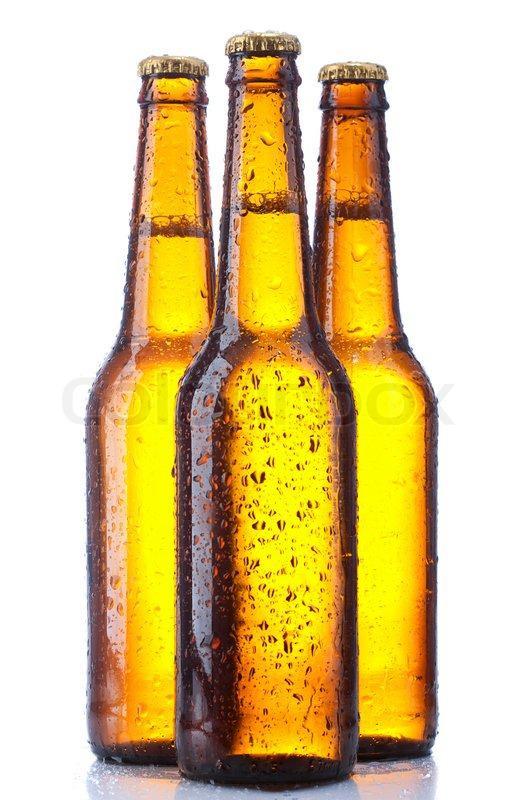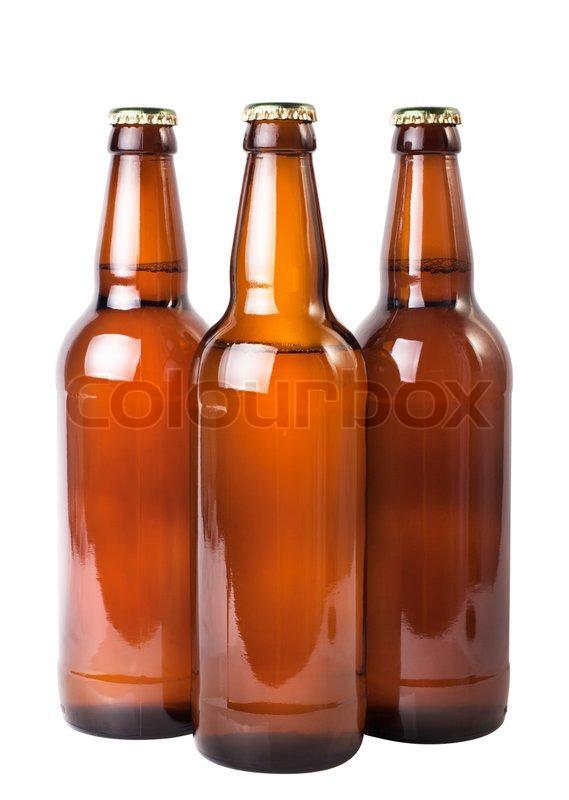The first image is the image on the left, the second image is the image on the right. Considering the images on both sides, is "One set of bottles is yellow and the other set is more brown." valid? Answer yes or no. Yes. The first image is the image on the left, the second image is the image on the right. Assess this claim about the two images: "All bottles are shown in groups of three and are capped.". Correct or not? Answer yes or no. Yes. 